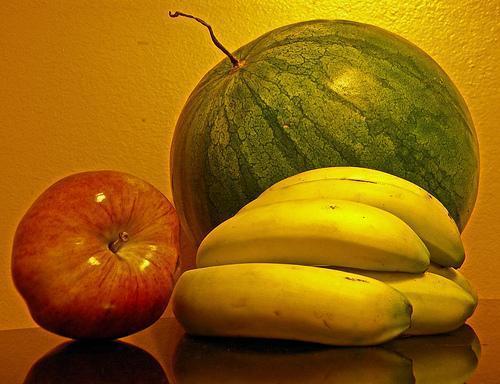How many bananas are there?
Give a very brief answer. 5. 